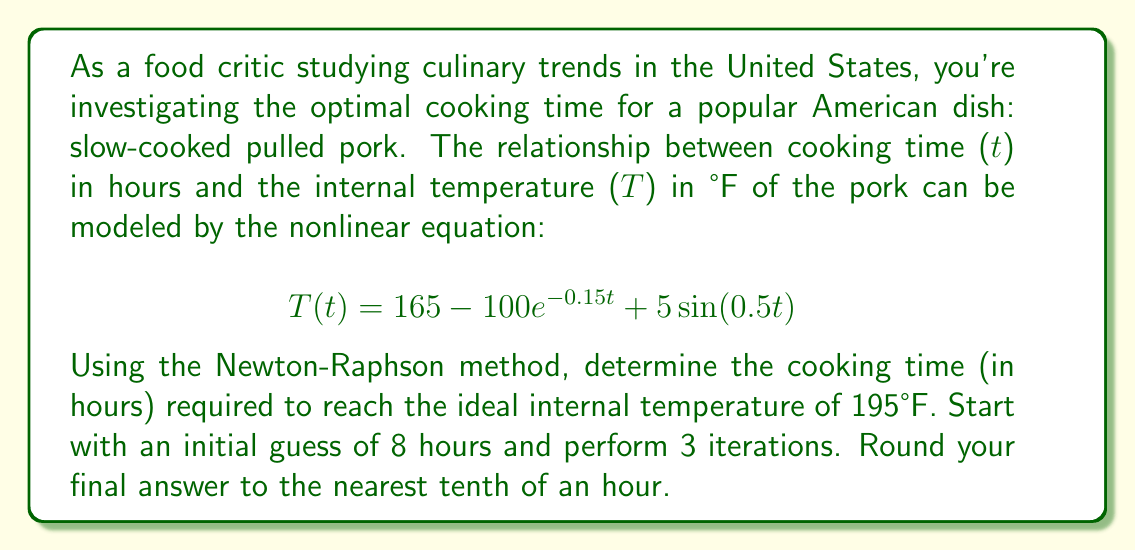Show me your answer to this math problem. To solve this problem, we'll use the Newton-Raphson method for finding roots of nonlinear equations. We want to find t such that T(t) = 195°F.

Step 1: Define the function f(t) and its derivative f'(t)
$$ f(t) = T(t) - 195 = 165 - 100e^{-0.15t} + 5\sin(0.5t) - 195 $$
$$ f'(t) = 15e^{-0.15t} + 2.5\cos(0.5t) $$

Step 2: Apply the Newton-Raphson formula for 3 iterations
$$ t_{n+1} = t_n - \frac{f(t_n)}{f'(t_n)} $$

Initial guess: $t_0 = 8$

Iteration 1:
$$ f(8) = 165 - 100e^{-0.15(8)} + 5\sin(0.5(8)) - 195 = -11.7646 $$
$$ f'(8) = 15e^{-0.15(8)} + 2.5\cos(0.5(8)) = 3.0928 $$
$$ t_1 = 8 - \frac{-11.7646}{3.0928} = 11.8031 $$

Iteration 2:
$$ f(11.8031) = -0.4697 $$
$$ f'(11.8031) = 1.7999 $$
$$ t_2 = 11.8031 - \frac{-0.4697}{1.7999} = 12.0641 $$

Iteration 3:
$$ f(12.0641) = -0.0007 $$
$$ f'(12.0641) = 1.7551 $$
$$ t_3 = 12.0641 - \frac{-0.0007}{1.7551} = 12.0645 $$

Step 3: Round the result to the nearest tenth
12.0645 rounded to the nearest tenth is 12.1 hours.
Answer: 12.1 hours 